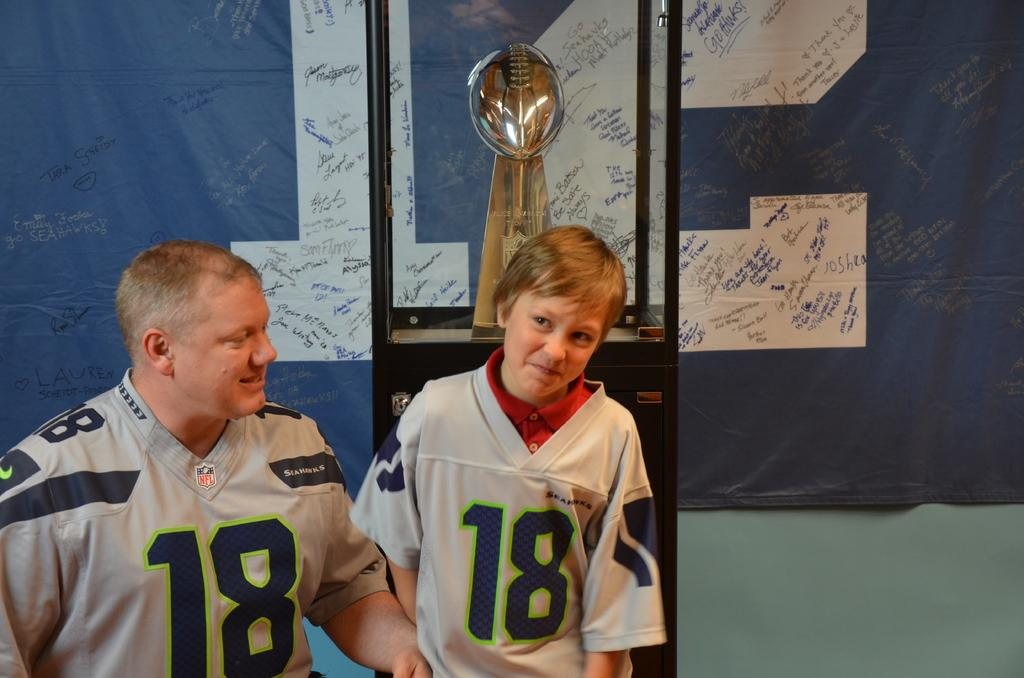<image>
Render a clear and concise summary of the photo. a boy wearing number 18 on his jersey stands next a man wearing number 18 as well 